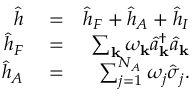Convert formula to latex. <formula><loc_0><loc_0><loc_500><loc_500>\begin{array} { r l r } { \hat { h } } & = } & { \hat { h } _ { F } + \hat { h } _ { A } + \hat { h } _ { I } } \\ { \hat { h } _ { F } } & = } & { \sum _ { k } \omega _ { k } \hat { a } _ { k } ^ { \dagger } \hat { a } _ { k } } \\ { \hat { h } _ { A } } & = } & { \sum _ { j = 1 } ^ { N _ { A } } \omega _ { j } \hat { \sigma } _ { j } . } \end{array}</formula> 